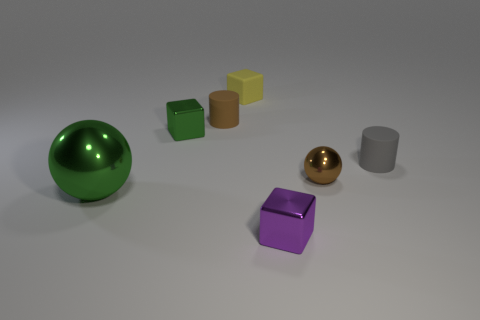There is a shiny object in front of the big green object; how many brown matte things are on the left side of it?
Provide a succinct answer. 1. Is the color of the rubber cube the same as the large metallic thing?
Give a very brief answer. No. What number of other objects are there of the same material as the yellow object?
Provide a short and direct response. 2. The tiny shiny thing on the left side of the cube in front of the big green metal sphere is what shape?
Provide a short and direct response. Cube. There is a metal block that is left of the purple block; how big is it?
Provide a succinct answer. Small. Does the green block have the same material as the small yellow thing?
Provide a short and direct response. No. The small brown thing that is made of the same material as the purple object is what shape?
Make the answer very short. Sphere. Are there any other things that are the same color as the big object?
Provide a succinct answer. Yes. What is the color of the ball in front of the brown shiny object?
Provide a succinct answer. Green. There is a big ball in front of the tiny brown cylinder; is it the same color as the tiny rubber cube?
Offer a terse response. No. 